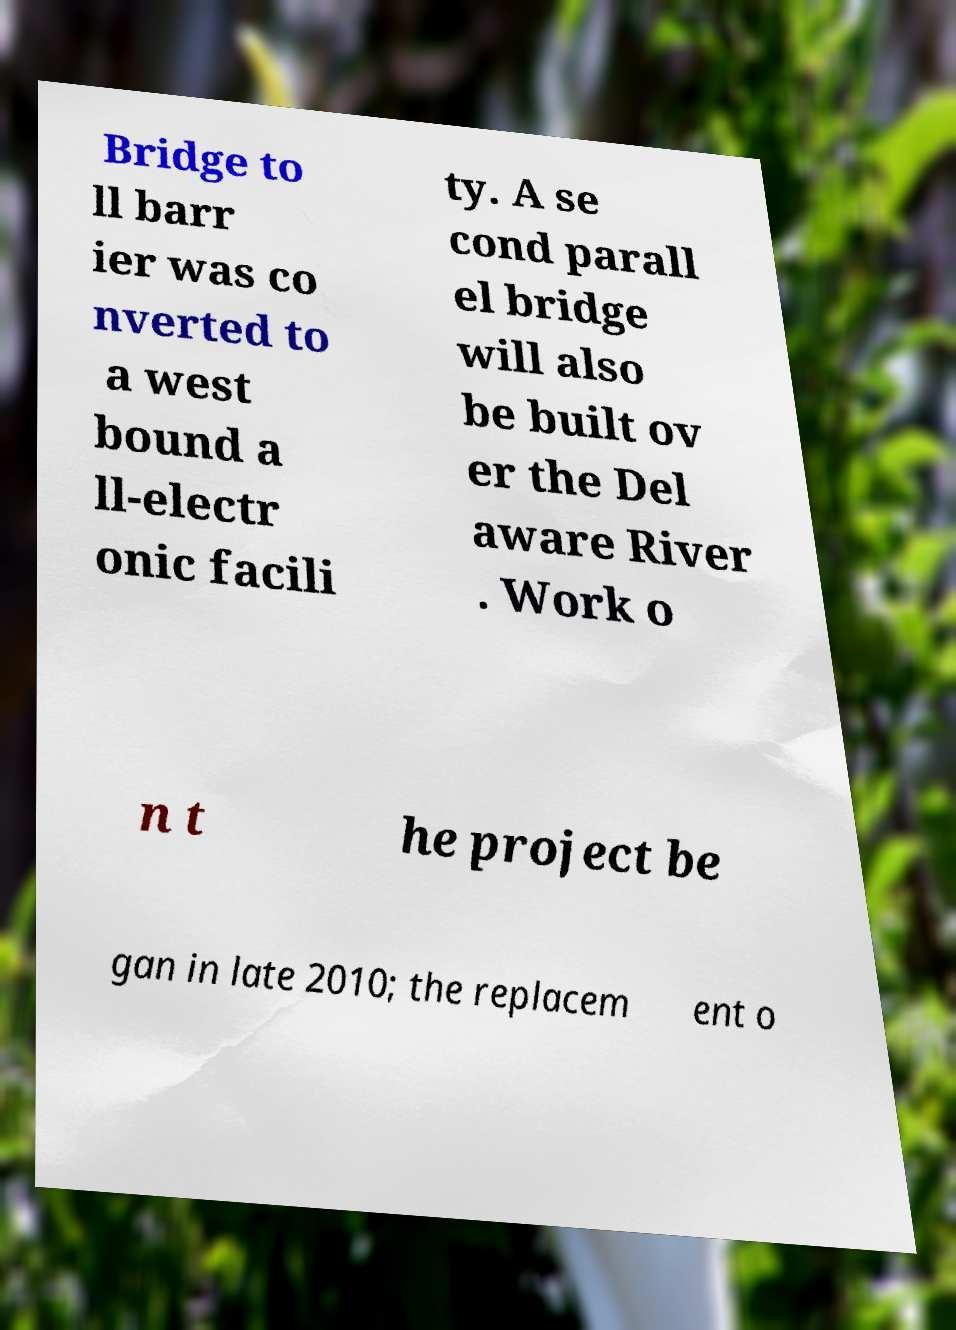Can you read and provide the text displayed in the image?This photo seems to have some interesting text. Can you extract and type it out for me? Bridge to ll barr ier was co nverted to a west bound a ll-electr onic facili ty. A se cond parall el bridge will also be built ov er the Del aware River . Work o n t he project be gan in late 2010; the replacem ent o 